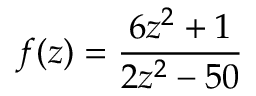<formula> <loc_0><loc_0><loc_500><loc_500>f ( z ) = { \frac { 6 z ^ { 2 } + 1 } { 2 z ^ { 2 } - 5 0 } }</formula> 